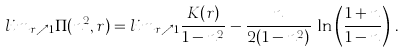Convert formula to latex. <formula><loc_0><loc_0><loc_500><loc_500>l i m _ { r \nearrow 1 } \Pi ( n ^ { 2 } , r ) = l i m _ { r \nearrow 1 } \frac { K ( r ) } { 1 - n ^ { 2 } } - \frac { n } { 2 ( 1 - n ^ { 2 } ) } \, \ln \left ( \frac { 1 + n } { 1 - n } \right ) \, .</formula> 